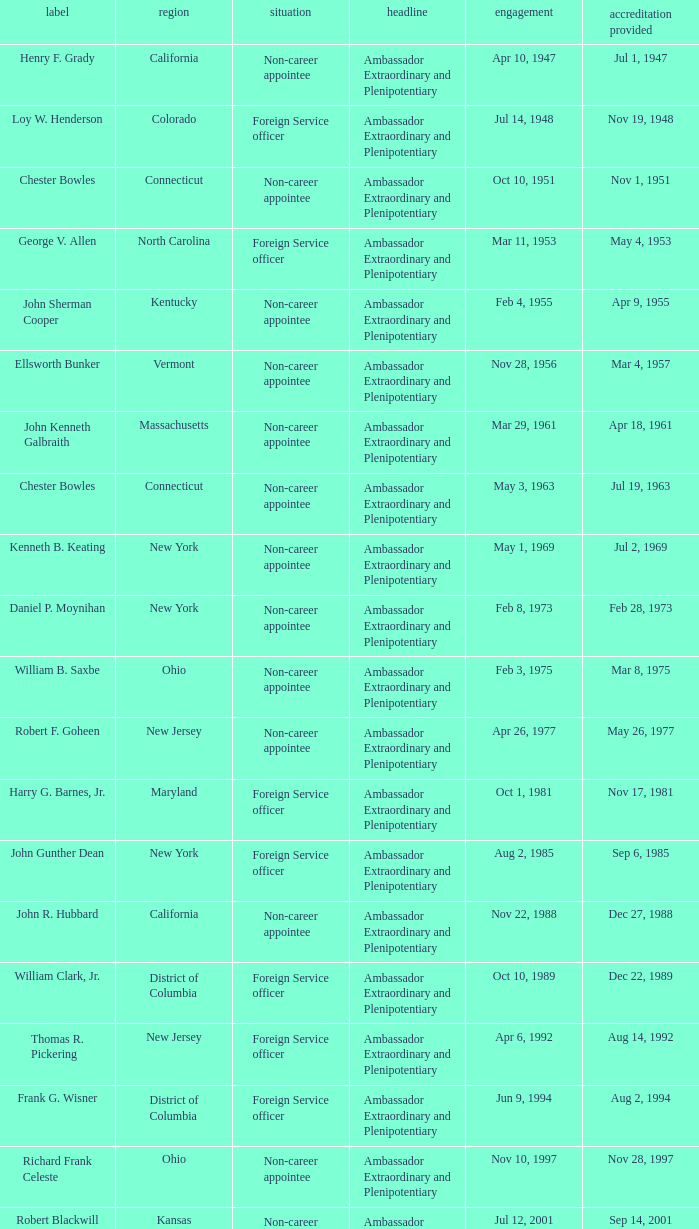What state has an appointment for jul 12, 2001? Kansas. 